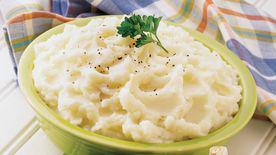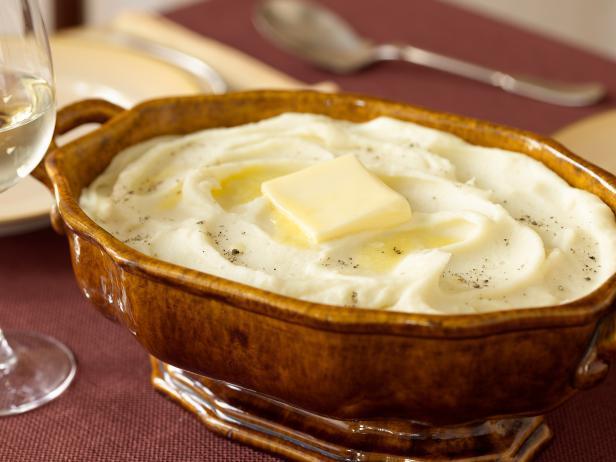The first image is the image on the left, the second image is the image on the right. Considering the images on both sides, is "The right hand dish has slightly fluted edges." valid? Answer yes or no. Yes. 